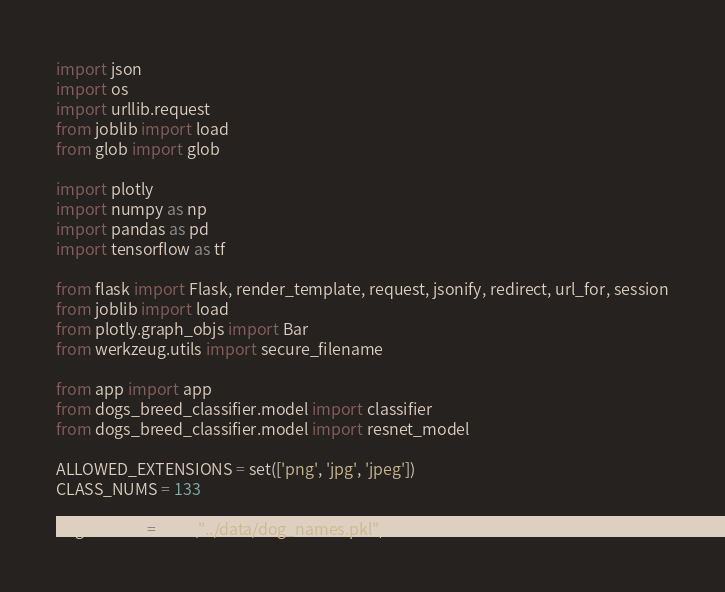<code> <loc_0><loc_0><loc_500><loc_500><_Python_>import json
import os
import urllib.request
from joblib import load
from glob import glob

import plotly
import numpy as np
import pandas as pd
import tensorflow as tf

from flask import Flask, render_template, request, jsonify, redirect, url_for, session
from joblib import load
from plotly.graph_objs import Bar
from werkzeug.utils import secure_filename

from app import app
from dogs_breed_classifier.model import classifier
from dogs_breed_classifier.model import resnet_model

ALLOWED_EXTENSIONS = set(['png', 'jpg', 'jpeg'])
CLASS_NUMS = 133

dog_names = load("../data/dog_names.pkl")
</code> 